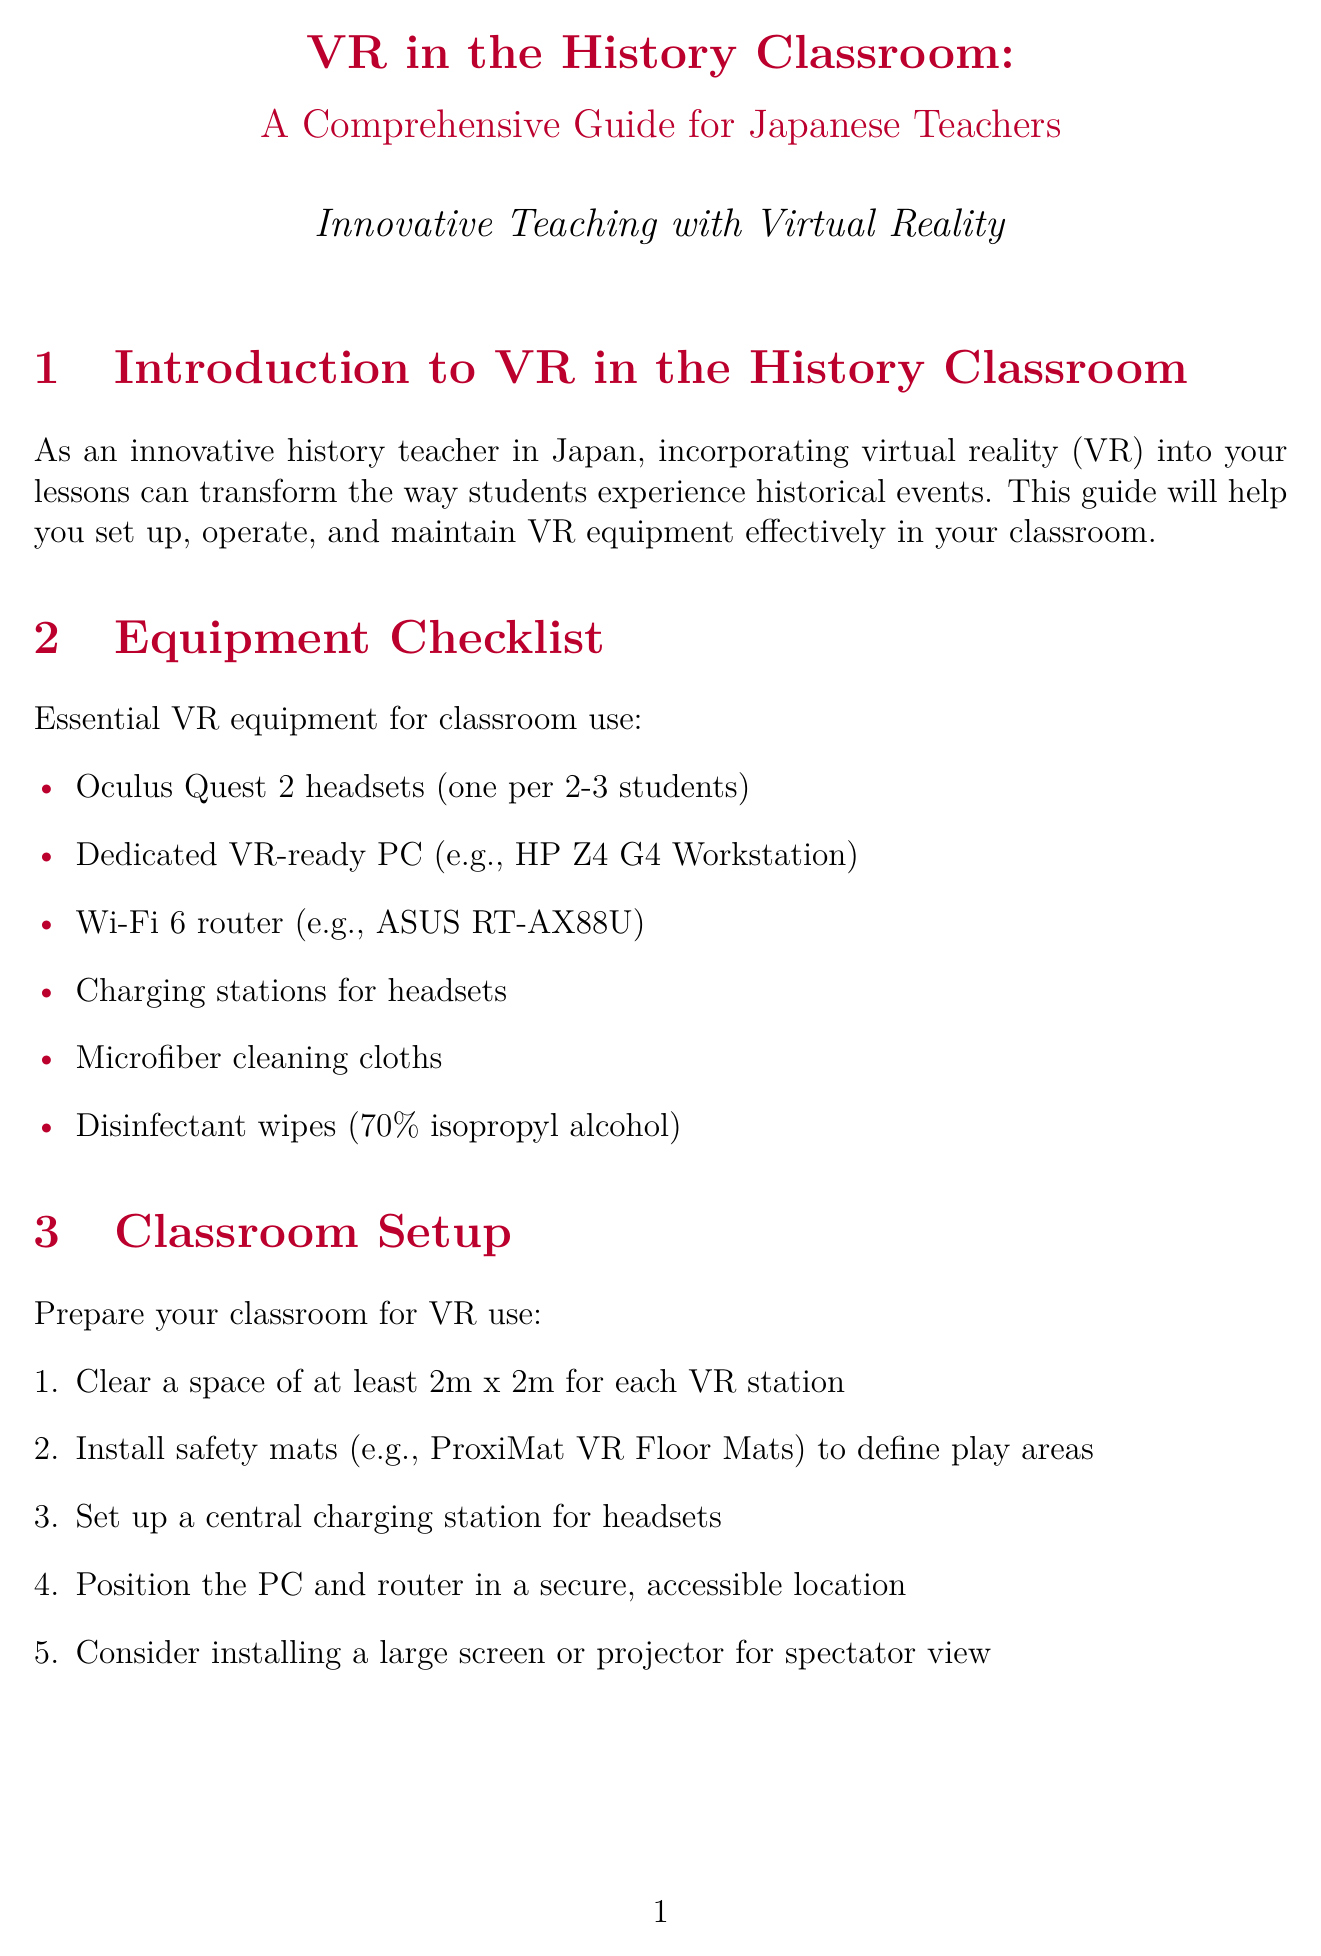What is the recommended number of Oculus Quest 2 headsets per students? The document states that one Oculus Quest 2 headset is recommended for every 2-3 students.
Answer: one per 2-3 students What is one app recommended for Japanese history? The document lists educational VR apps, including those specifically for Japanese history, like Edo VR and Samurai VR Experience.
Answer: Edo VR How far should a space be cleared for each VR station? The recommended space clearance for each VR station is indicated in the classroom setup section.
Answer: 2m x 2m What should be used to disinfect face cushions? The maintenance section specifies the use of alcohol wipes for disinfecting face cushions.
Answer: alcohol wipes What is the maximum recommended duration for VR sessions? The safety guidelines state a maximum duration to limit potential discomfort during VR use.
Answer: 20-30 minutes What type of station should be set up for charging headsets? The classroom setup section mentions a specific station to be set up for charging purposes.
Answer: central charging station Which software is suggested for additional content options beyond Oculus? The installation section recommends setting up Steam VR for additional content options besides Oculus.
Answer: Steam VR What is a regular maintenance task listed for headsets? The document outlines regular maintenance tasks, one of which is cleaning the headset lenses after each use.
Answer: Clean headset lenses What cultural consideration is emphasized for managing shared equipment? The cultural considerations section highlights the importance of maintaining etiquette when using equipment.
Answer: proper etiquette 